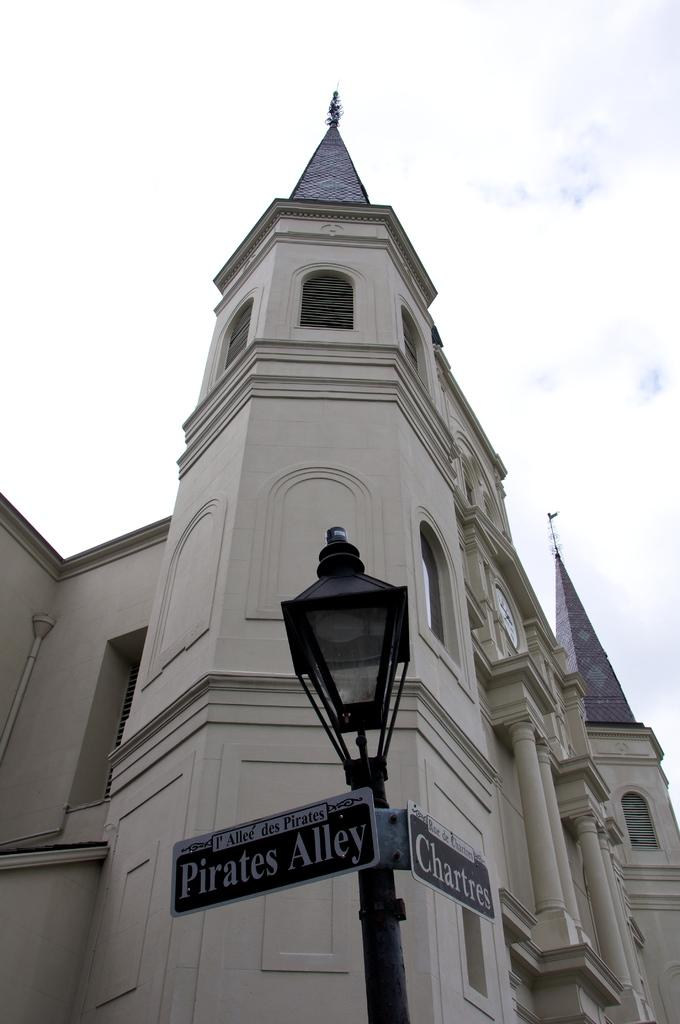What is the main object in the center of the image? There is a sign and a lamp pole in the center of the image. Can you describe the background of the image? There is a building in the background of the image. What is the profit margin of the silver range in the image? There is no mention of profit, silver, or a range in the image, so it is not possible to determine the profit margin. 